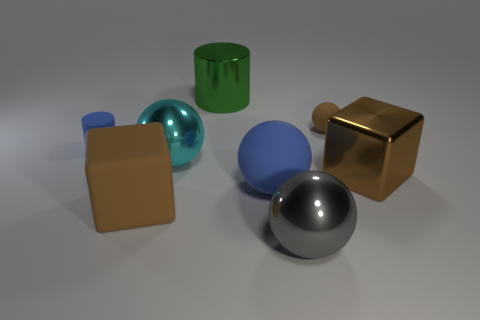Are there the same number of tiny things that are in front of the gray ball and big purple blocks?
Your answer should be very brief. Yes. Is there a thing that is on the left side of the big brown cube left of the large brown object that is right of the large cylinder?
Your response must be concise. Yes. What is the big green object made of?
Your answer should be compact. Metal. What number of other things are the same shape as the green metal thing?
Provide a succinct answer. 1. Is the big green shiny thing the same shape as the small blue object?
Your response must be concise. Yes. What number of things are cyan objects on the left side of the large gray metallic object or big things behind the gray sphere?
Your answer should be very brief. 5. How many things are cyan objects or tiny blue rubber things?
Keep it short and to the point. 2. What number of small spheres are to the right of the metal object behind the blue cylinder?
Provide a succinct answer. 1. What number of other things are the same size as the cyan metal sphere?
Provide a short and direct response. 5. There is a rubber object that is the same color as the large matte ball; what size is it?
Ensure brevity in your answer.  Small. 